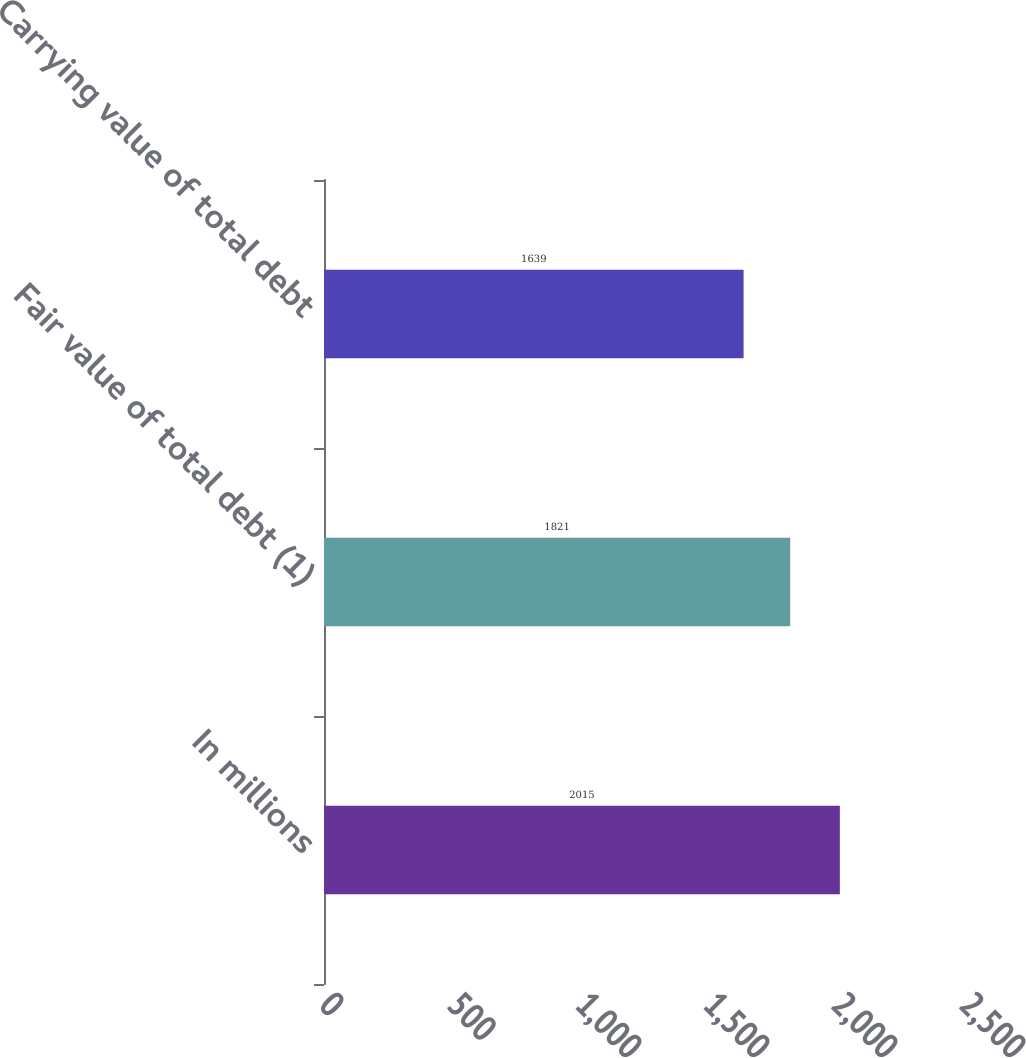<chart> <loc_0><loc_0><loc_500><loc_500><bar_chart><fcel>In millions<fcel>Fair value of total debt (1)<fcel>Carrying value of total debt<nl><fcel>2015<fcel>1821<fcel>1639<nl></chart> 